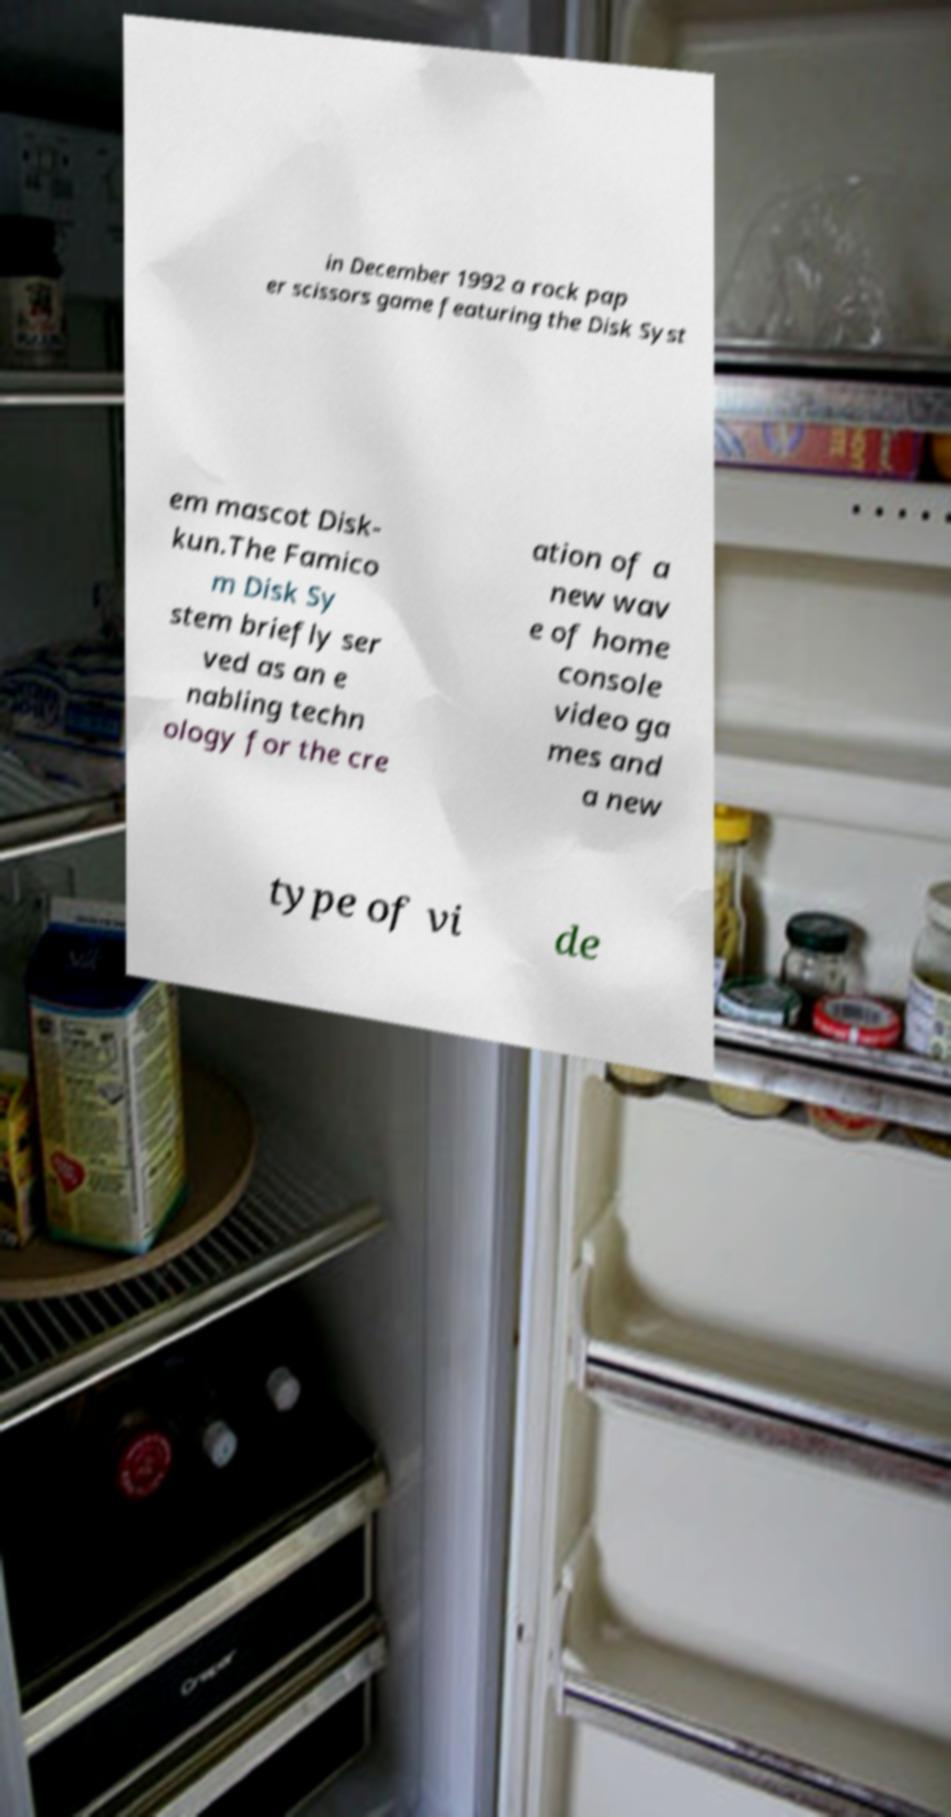Please read and relay the text visible in this image. What does it say? in December 1992 a rock pap er scissors game featuring the Disk Syst em mascot Disk- kun.The Famico m Disk Sy stem briefly ser ved as an e nabling techn ology for the cre ation of a new wav e of home console video ga mes and a new type of vi de 